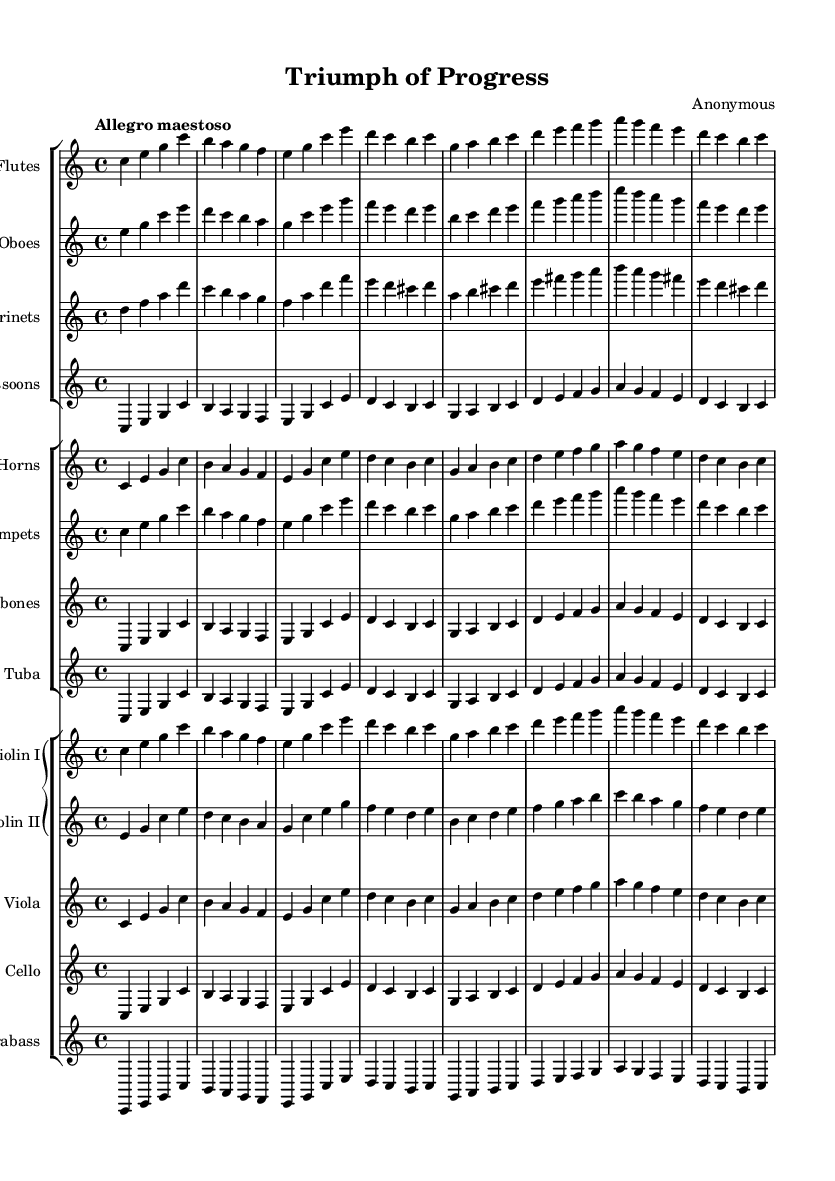What is the key signature of this music? The key signature is C major, which has no sharps or flats.
Answer: C major What is the time signature of this music? The time signature is indicated as 4/4, meaning there are 4 beats per measure and the quarter note gets one beat.
Answer: 4/4 What is the tempo marking for this symphony? The tempo marking is "Allegro maestoso," which indicates a lively and majestic tempo.
Answer: Allegro maestoso How many different types of woodwind instruments are in this score? There are three types of woodwind instruments: flute, oboe, and clarinet. Counting these gives us three distinct types.
Answer: Three What are the starting pitches of the first violin part? The first violin starts on C, then ascends to E and G, which are the first three notes of the piece.
Answer: C, E, G Which section contains the tuba? The tuba is part of the brass section, which includes horns, trumpets, trombones, and the tuba itself.
Answer: Brass section How does this symphony celebrate national achievements? The triumphant character of the symphony, showcased through its grand orchestration and majestic tempo, reflects and celebrates national pride and historical milestones.
Answer: Through triumphant character 